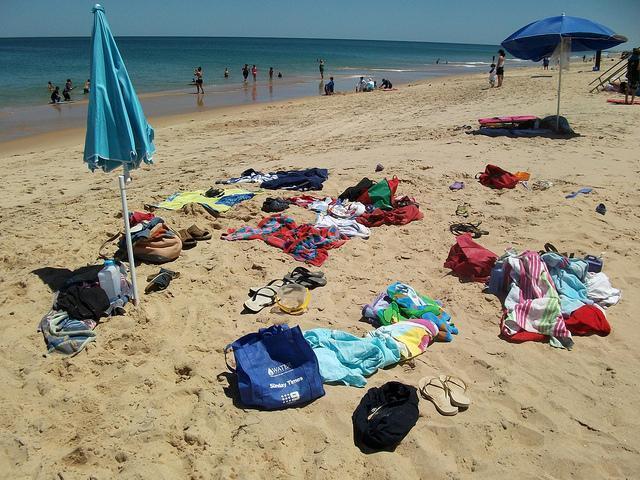How many umbrellas are in the picture?
Give a very brief answer. 2. How many handbags are in the picture?
Give a very brief answer. 2. 